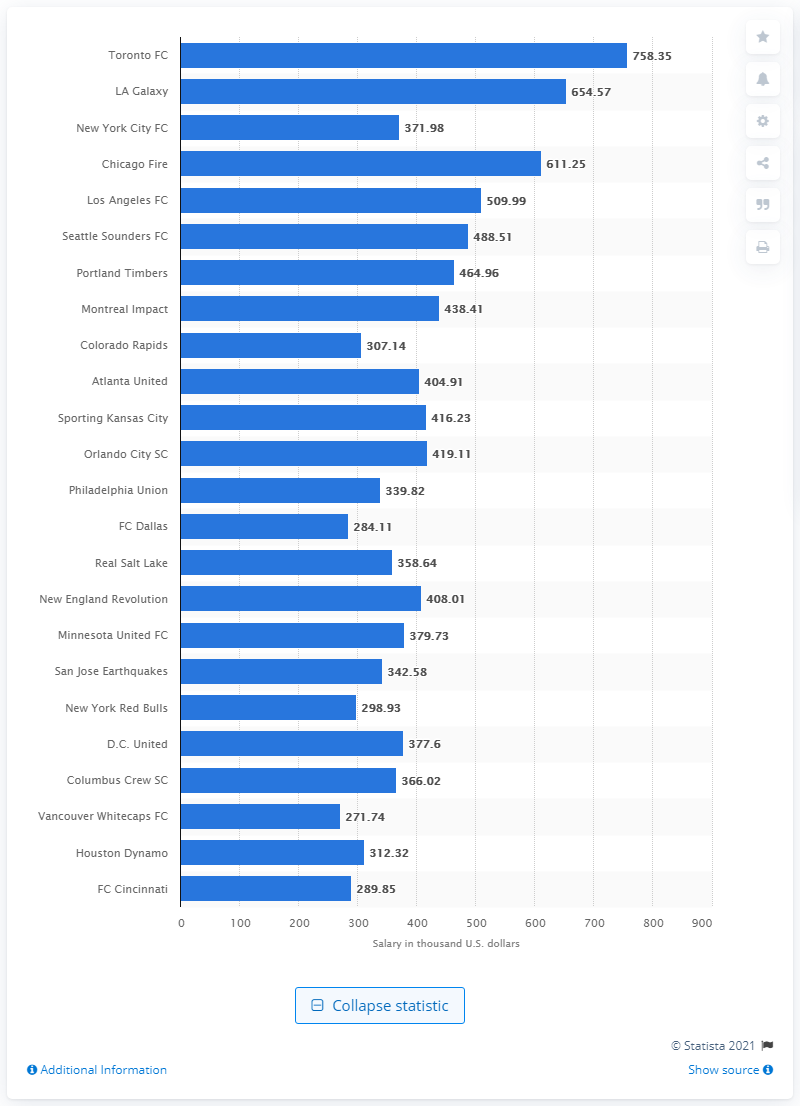Outline some significant characteristics in this image. The average player salary in Toronto FC in 2019 was approximately $758.35 per player, in United States dollars. 